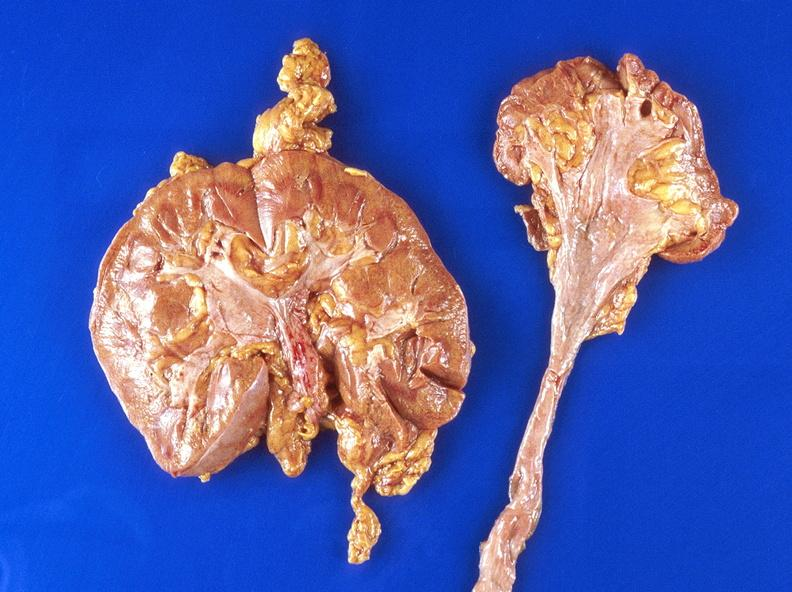what does this image show?
Answer the question using a single word or phrase. Hydronephrosis 